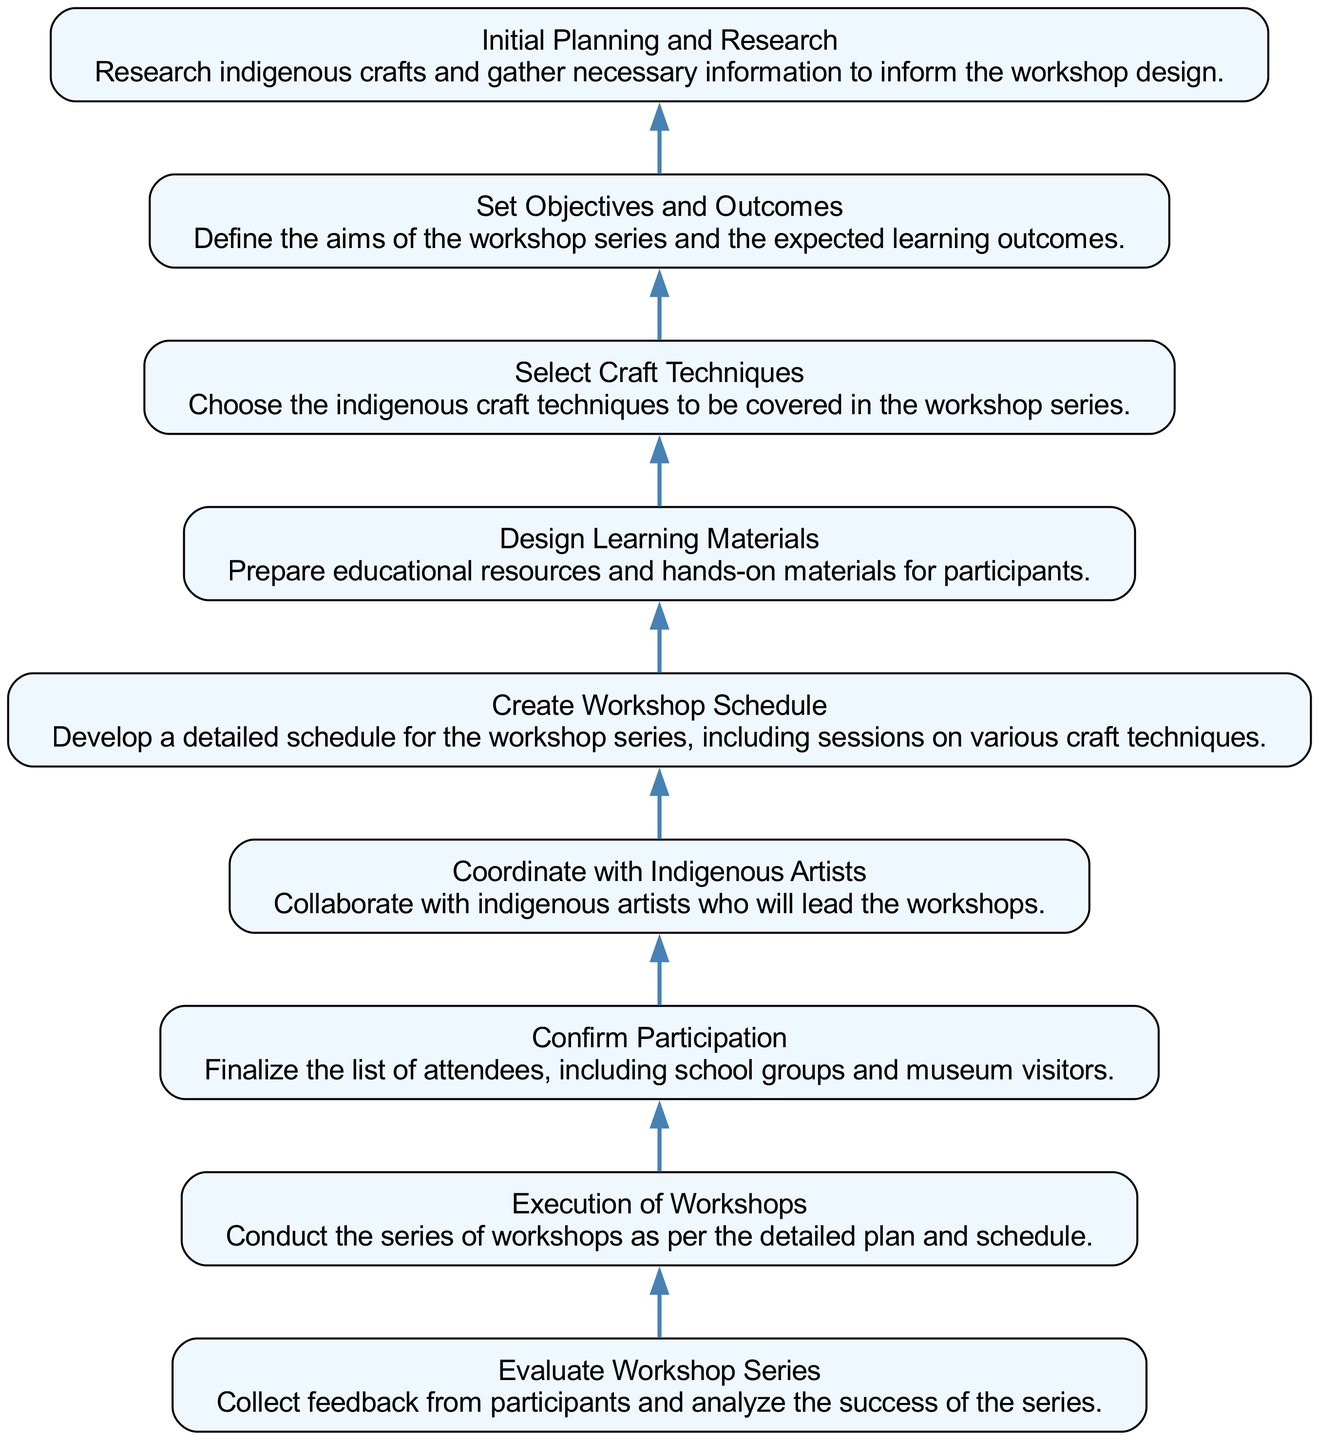What is the final step in the workshop series? The final step is to "Evaluate Workshop Series". This is the last item in the flow, indicating that feedback is collected after the workshops are conducted.
Answer: Evaluate Workshop Series How many total steps are there in the workshop planning process? By counting each distinct node in the diagram, there are a total of 9 steps in the workshop planning process.
Answer: 9 What comes immediately after "Select Craft Techniques"? The immediate next step after "Select Craft Techniques" is "Set Objectives and Outcomes". This follows the flow of the diagram where one task leads to the next.
Answer: Set Objectives and Outcomes Which step involves preparing educational resources? The step that involves preparing educational resources and hands-on materials is "Design Learning Materials". This step is directly connected to "Create Workshop Schedule".
Answer: Design Learning Materials Which two steps are directly connected to "Confirm Participation"? The two steps directly connected to "Confirm Participation" are "Execution of Workshops" and "Coordinate with Indigenous Artists". These steps follow the confirmation of who will attend the workshops.
Answer: Execution of Workshops, Coordinate with Indigenous Artists What is the first step in the process? The first step in the workshop process is "Initial Planning and Research". It sets the foundation for all subsequent activities by gathering necessary information prior to any execution.
Answer: Initial Planning and Research How does the diagram show the relationship between "Evaluate Workshop Series" and the previous steps? "Evaluate Workshop Series" is the final step, indicating no steps follow it. Its connection shows that it relies on the successful conduct of all previous workshops. It is dependent on having the workshops executed and receives evaluations from the participants.
Answer: No steps follow it What action is taken after participants are confirmed? After confirming participants, the action taken is "Coordinate with Indigenous Artists". It indicates the necessity to finalize artist collaborations once participants are known.
Answer: Coordinate with Indigenous Artists What is the purpose of the "Set Objectives and Outcomes" step? The purpose of "Set Objectives and Outcomes" is to define the aims of the workshop series and expected learning outcomes, ensuring clarity in what the series intends to achieve.
Answer: Define aims and expected outcomes 